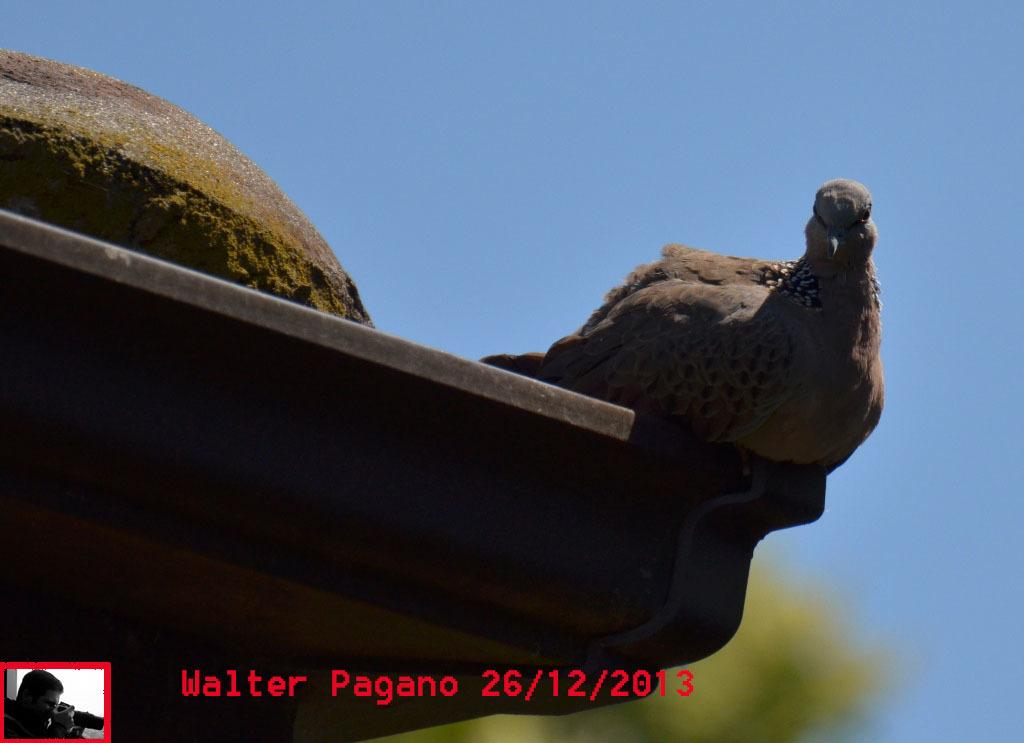What type of animal is on the flat surface in the image? There is a bird on a flat surface in the image. What is the person in the image doing? The person in the image is holding a camera. What else can be seen on the image besides the bird and the person? There is text visible on the image. What type of plate is the bird sitting on in the image? There is no plate present in the image; the bird is on a flat surface. What is the bird using to attach itself to the person's head in the image? There is no bird attached to the person's head in the image, and there is no hook present. 